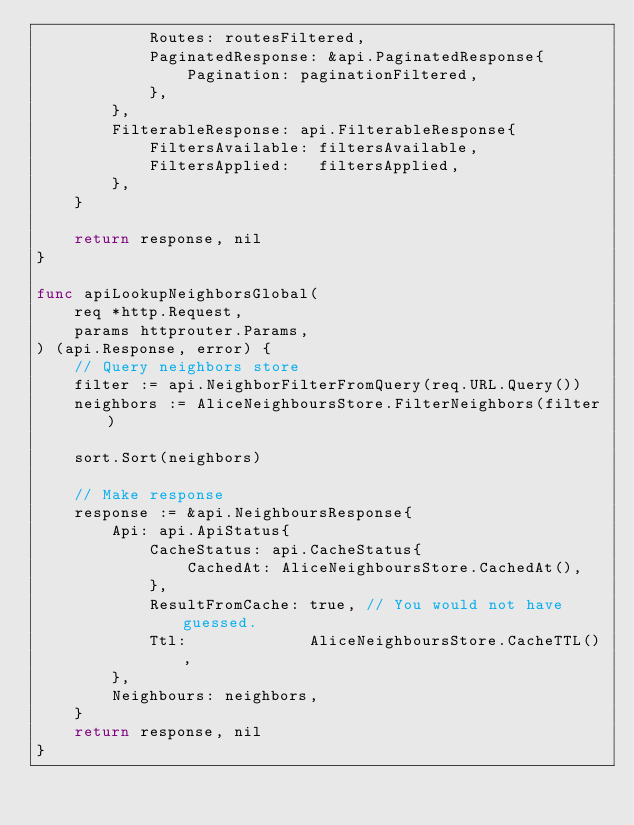Convert code to text. <code><loc_0><loc_0><loc_500><loc_500><_Go_>			Routes: routesFiltered,
			PaginatedResponse: &api.PaginatedResponse{
				Pagination: paginationFiltered,
			},
		},
		FilterableResponse: api.FilterableResponse{
			FiltersAvailable: filtersAvailable,
			FiltersApplied:   filtersApplied,
		},
	}

	return response, nil
}

func apiLookupNeighborsGlobal(
	req *http.Request,
	params httprouter.Params,
) (api.Response, error) {
	// Query neighbors store
	filter := api.NeighborFilterFromQuery(req.URL.Query())
	neighbors := AliceNeighboursStore.FilterNeighbors(filter)

	sort.Sort(neighbors)

	// Make response
	response := &api.NeighboursResponse{
		Api: api.ApiStatus{
			CacheStatus: api.CacheStatus{
				CachedAt: AliceNeighboursStore.CachedAt(),
			},
			ResultFromCache: true, // You would not have guessed.
			Ttl:             AliceNeighboursStore.CacheTTL(),
		},
		Neighbours: neighbors,
	}
	return response, nil
}
</code> 